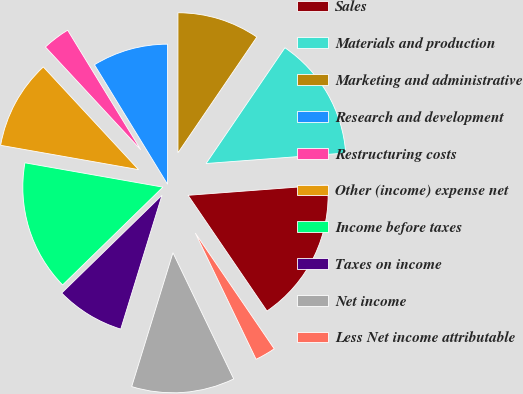<chart> <loc_0><loc_0><loc_500><loc_500><pie_chart><fcel>Sales<fcel>Materials and production<fcel>Marketing and administrative<fcel>Research and development<fcel>Restructuring costs<fcel>Other (income) expense net<fcel>Income before taxes<fcel>Taxes on income<fcel>Net income<fcel>Less Net income attributable<nl><fcel>16.67%<fcel>14.29%<fcel>9.52%<fcel>8.73%<fcel>3.17%<fcel>10.32%<fcel>15.08%<fcel>7.94%<fcel>11.9%<fcel>2.38%<nl></chart> 